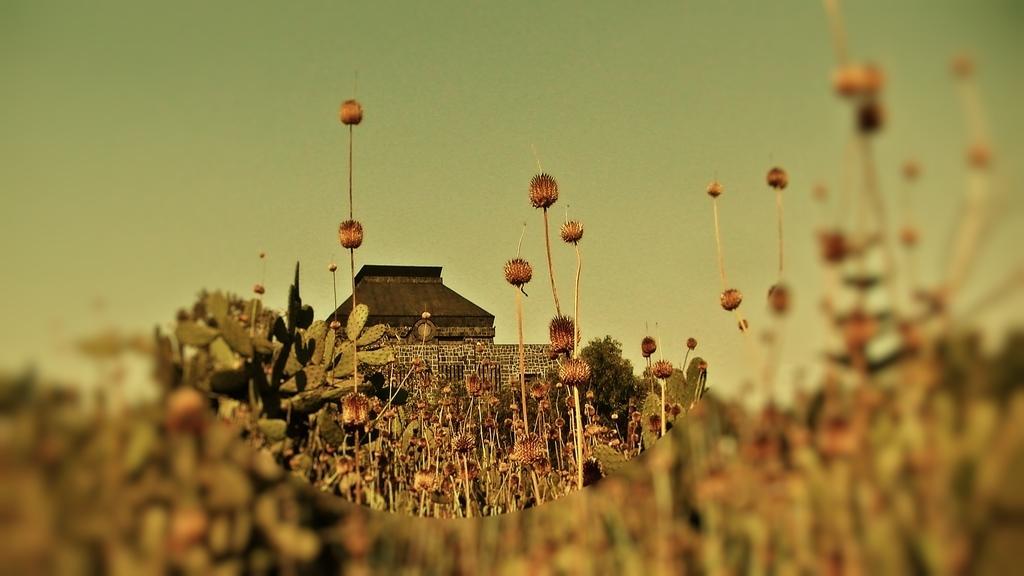Can you describe this image briefly? In this image we can see some flowers, plants, trees, house and the sky. 